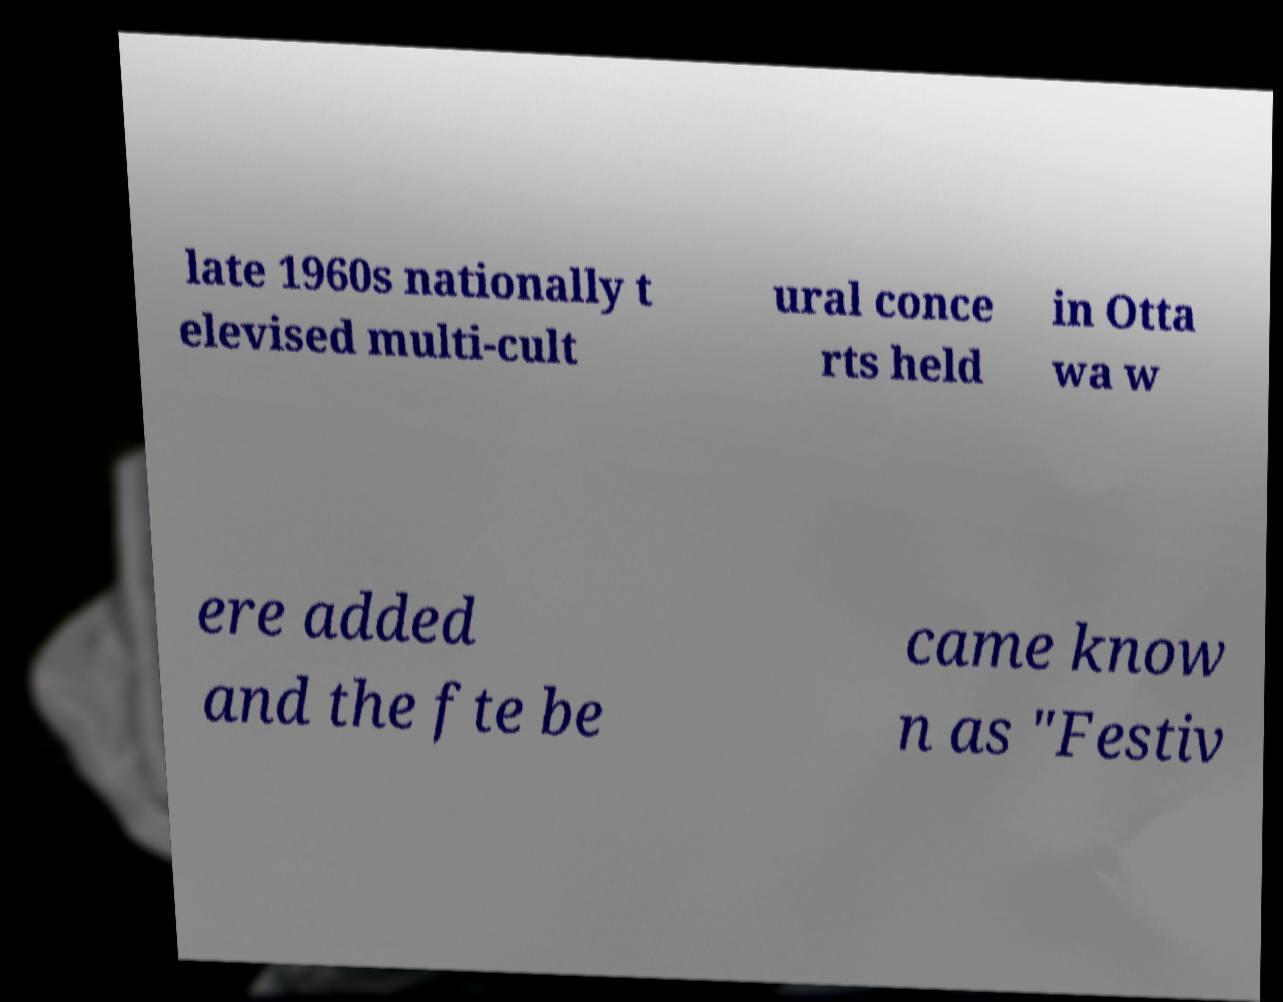Can you read and provide the text displayed in the image?This photo seems to have some interesting text. Can you extract and type it out for me? late 1960s nationally t elevised multi-cult ural conce rts held in Otta wa w ere added and the fte be came know n as "Festiv 